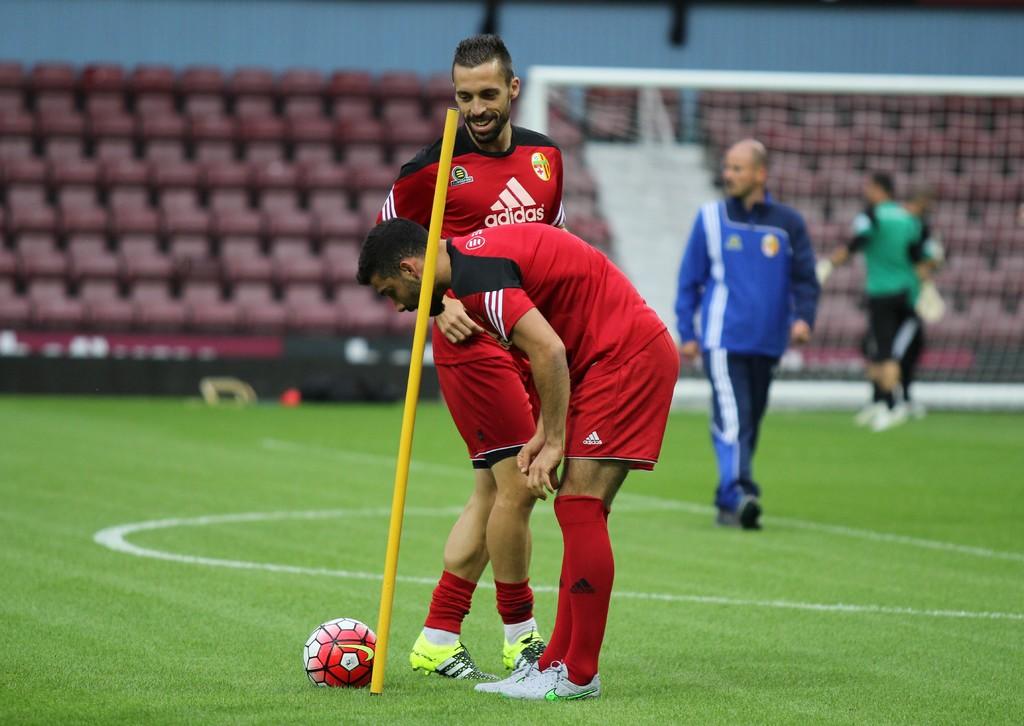What brand is on the red shirt?
Your answer should be compact. Adidas. Is the word adidas on the front of the man's shirt near the front ?
Make the answer very short. Yes. 